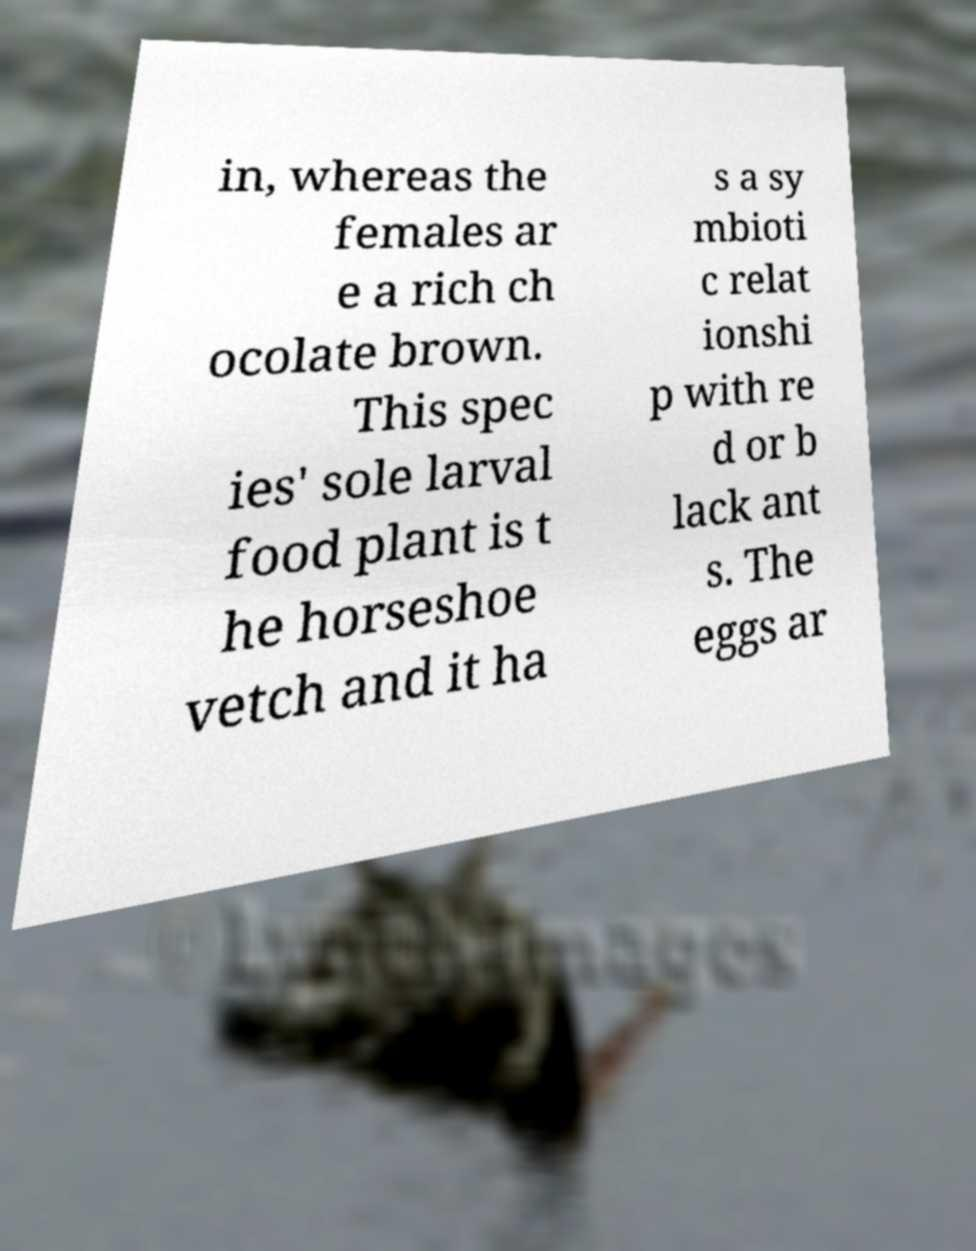Could you assist in decoding the text presented in this image and type it out clearly? in, whereas the females ar e a rich ch ocolate brown. This spec ies' sole larval food plant is t he horseshoe vetch and it ha s a sy mbioti c relat ionshi p with re d or b lack ant s. The eggs ar 